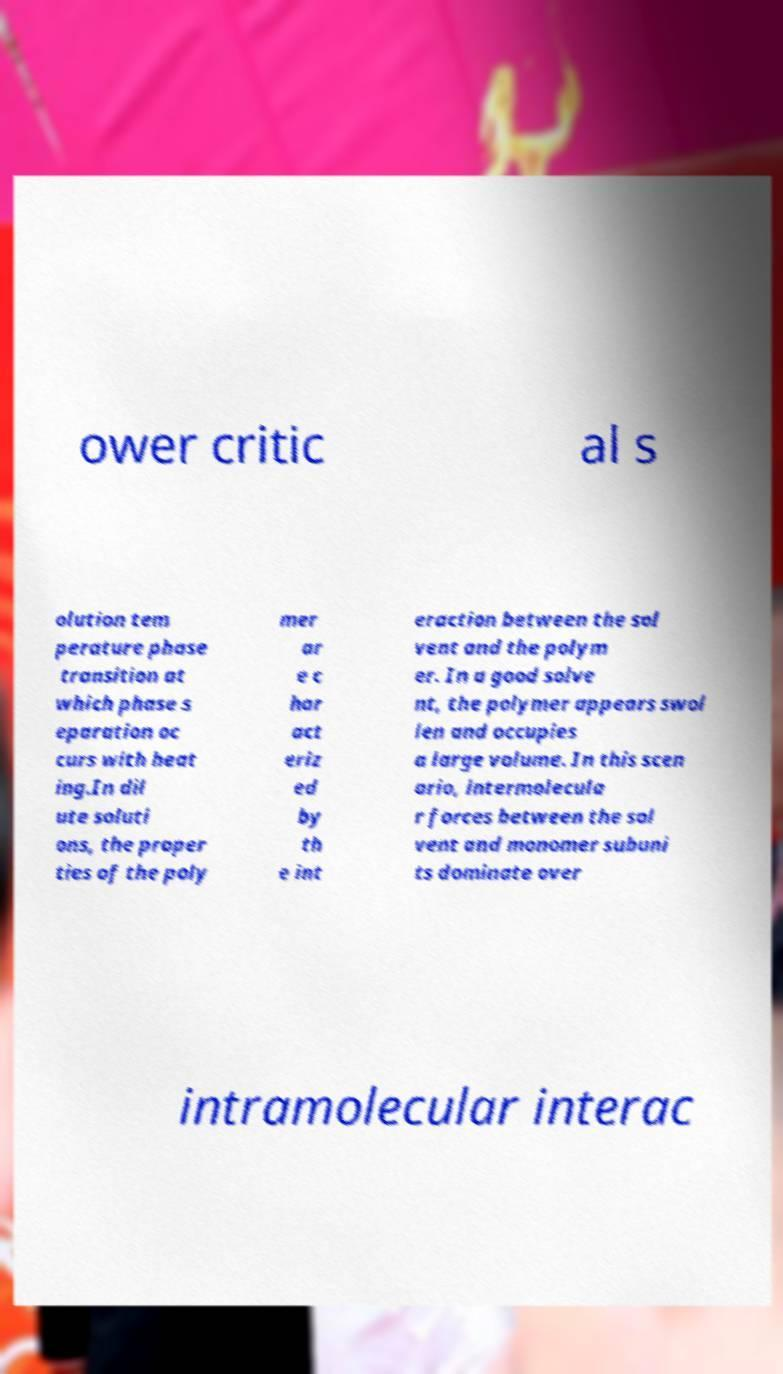Please identify and transcribe the text found in this image. ower critic al s olution tem perature phase transition at which phase s eparation oc curs with heat ing.In dil ute soluti ons, the proper ties of the poly mer ar e c har act eriz ed by th e int eraction between the sol vent and the polym er. In a good solve nt, the polymer appears swol len and occupies a large volume. In this scen ario, intermolecula r forces between the sol vent and monomer subuni ts dominate over intramolecular interac 